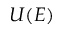<formula> <loc_0><loc_0><loc_500><loc_500>U ( E )</formula> 